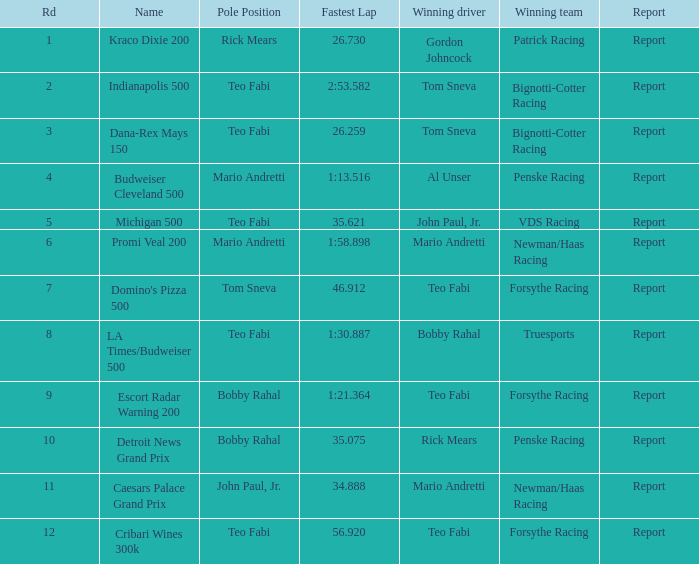What is the maximum rd where tom sneva held the pole position? 7.0. 